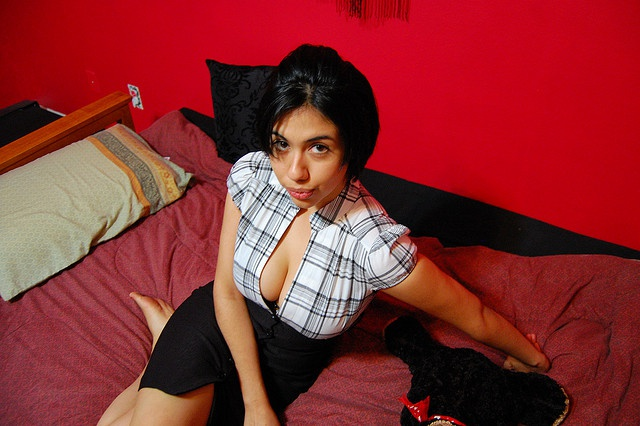Describe the objects in this image and their specific colors. I can see bed in maroon, black, brown, and darkgray tones, people in maroon, black, lightgray, and tan tones, and teddy bear in maroon, black, and brown tones in this image. 